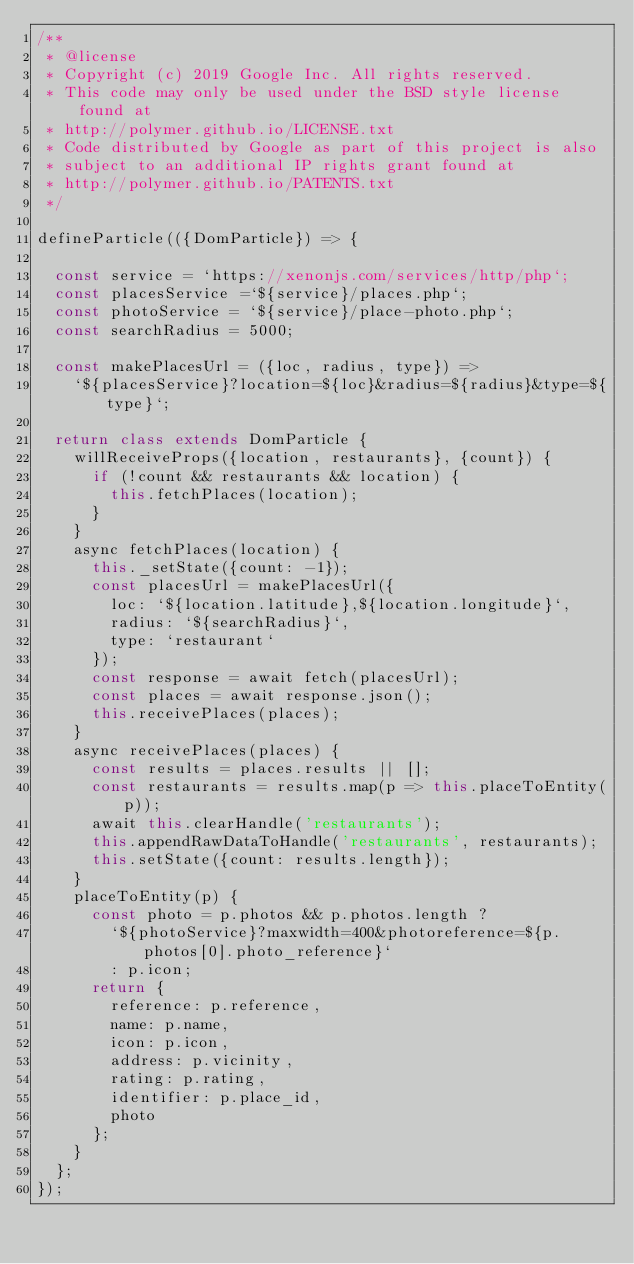<code> <loc_0><loc_0><loc_500><loc_500><_JavaScript_>/**
 * @license
 * Copyright (c) 2019 Google Inc. All rights reserved.
 * This code may only be used under the BSD style license found at
 * http://polymer.github.io/LICENSE.txt
 * Code distributed by Google as part of this project is also
 * subject to an additional IP rights grant found at
 * http://polymer.github.io/PATENTS.txt
 */

defineParticle(({DomParticle}) => {

  const service = `https://xenonjs.com/services/http/php`;
  const placesService =`${service}/places.php`;
  const photoService = `${service}/place-photo.php`;
  const searchRadius = 5000;

  const makePlacesUrl = ({loc, radius, type}) =>
    `${placesService}?location=${loc}&radius=${radius}&type=${type}`;

  return class extends DomParticle {
    willReceiveProps({location, restaurants}, {count}) {
      if (!count && restaurants && location) {
        this.fetchPlaces(location);
      }
    }
    async fetchPlaces(location) {
      this._setState({count: -1});
      const placesUrl = makePlacesUrl({
        loc: `${location.latitude},${location.longitude}`,
        radius: `${searchRadius}`,
        type: `restaurant`
      });
      const response = await fetch(placesUrl);
      const places = await response.json();
      this.receivePlaces(places);
    }
    async receivePlaces(places) {
      const results = places.results || [];
      const restaurants = results.map(p => this.placeToEntity(p));
      await this.clearHandle('restaurants');
      this.appendRawDataToHandle('restaurants', restaurants);
      this.setState({count: results.length});
    }
    placeToEntity(p) {
      const photo = p.photos && p.photos.length ?
        `${photoService}?maxwidth=400&photoreference=${p.photos[0].photo_reference}`
        : p.icon;
      return {
        reference: p.reference,
        name: p.name,
        icon: p.icon,
        address: p.vicinity,
        rating: p.rating,
        identifier: p.place_id,
        photo
      };
    }
  };
});
</code> 